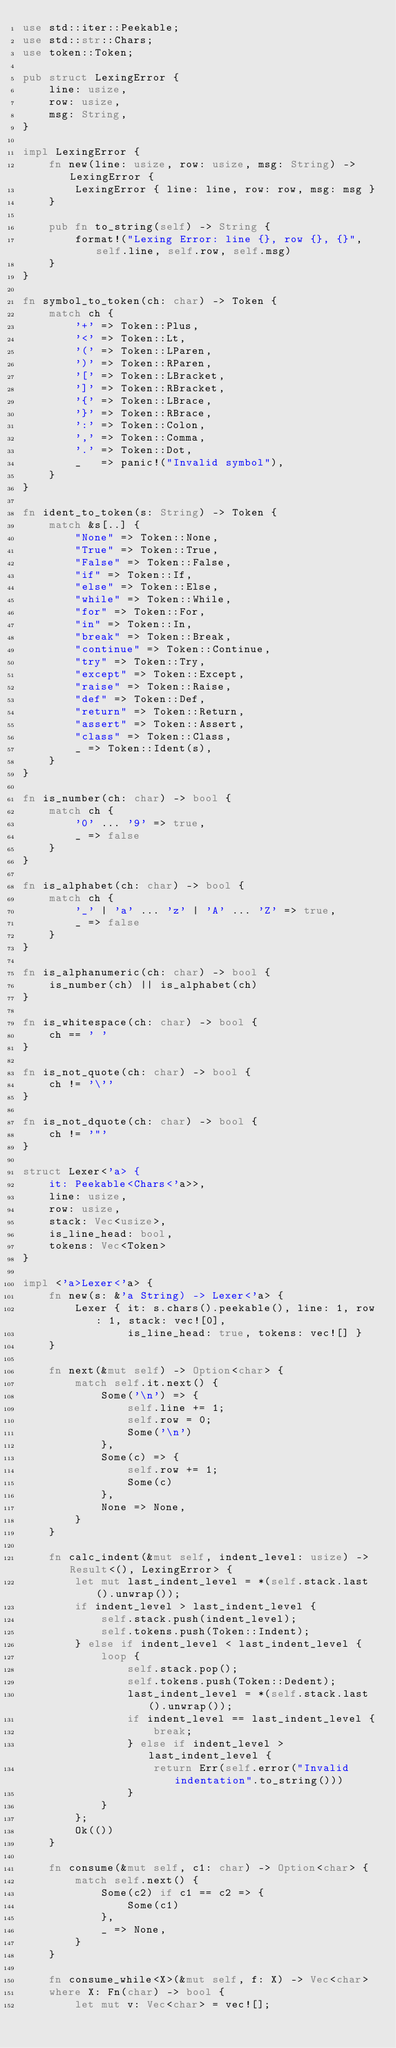<code> <loc_0><loc_0><loc_500><loc_500><_Rust_>use std::iter::Peekable;
use std::str::Chars;
use token::Token;

pub struct LexingError {
    line: usize,
    row: usize,
    msg: String,
}

impl LexingError {
    fn new(line: usize, row: usize, msg: String) -> LexingError {
        LexingError { line: line, row: row, msg: msg }
    }

    pub fn to_string(self) -> String {
        format!("Lexing Error: line {}, row {}, {}", self.line, self.row, self.msg)
    }
}

fn symbol_to_token(ch: char) -> Token {
    match ch {
        '+' => Token::Plus,
        '<' => Token::Lt,
        '(' => Token::LParen,
        ')' => Token::RParen,
        '[' => Token::LBracket,
        ']' => Token::RBracket,
        '{' => Token::LBrace,
        '}' => Token::RBrace,
        ':' => Token::Colon,
        ',' => Token::Comma,
        '.' => Token::Dot,
        _   => panic!("Invalid symbol"),
    }
}

fn ident_to_token(s: String) -> Token {
    match &s[..] {
        "None" => Token::None,
        "True" => Token::True,
        "False" => Token::False,
        "if" => Token::If,
        "else" => Token::Else,
        "while" => Token::While,
        "for" => Token::For,
        "in" => Token::In,
        "break" => Token::Break,
        "continue" => Token::Continue,
        "try" => Token::Try,
        "except" => Token::Except,
        "raise" => Token::Raise,
        "def" => Token::Def,
        "return" => Token::Return,
        "assert" => Token::Assert,
        "class" => Token::Class,
        _ => Token::Ident(s),
    }
}

fn is_number(ch: char) -> bool {
    match ch {
        '0' ... '9' => true,
        _ => false
    }
}

fn is_alphabet(ch: char) -> bool {
    match ch {
        '_' | 'a' ... 'z' | 'A' ... 'Z' => true,
        _ => false
    }
}

fn is_alphanumeric(ch: char) -> bool {
    is_number(ch) || is_alphabet(ch)
}

fn is_whitespace(ch: char) -> bool {
    ch == ' '
}

fn is_not_quote(ch: char) -> bool {
    ch != '\''
}

fn is_not_dquote(ch: char) -> bool {
    ch != '"'
}

struct Lexer<'a> {
    it: Peekable<Chars<'a>>,
    line: usize,
    row: usize,
    stack: Vec<usize>,
    is_line_head: bool,
    tokens: Vec<Token>
}

impl <'a>Lexer<'a> {
    fn new(s: &'a String) -> Lexer<'a> {
        Lexer { it: s.chars().peekable(), line: 1, row: 1, stack: vec![0],
                is_line_head: true, tokens: vec![] }
    }

    fn next(&mut self) -> Option<char> {
        match self.it.next() {
            Some('\n') => {
                self.line += 1;
                self.row = 0;
                Some('\n')
            },
            Some(c) => {
                self.row += 1;
                Some(c)
            },
            None => None,
        }
    }

    fn calc_indent(&mut self, indent_level: usize) -> Result<(), LexingError> {
        let mut last_indent_level = *(self.stack.last().unwrap());
        if indent_level > last_indent_level {
            self.stack.push(indent_level);
            self.tokens.push(Token::Indent);
        } else if indent_level < last_indent_level {
            loop {
                self.stack.pop();
                self.tokens.push(Token::Dedent);
                last_indent_level = *(self.stack.last().unwrap());
                if indent_level == last_indent_level {
                    break;
                } else if indent_level > last_indent_level {
                    return Err(self.error("Invalid indentation".to_string()))
                }
            }
        };
        Ok(())
    }

    fn consume(&mut self, c1: char) -> Option<char> {
        match self.next() {
            Some(c2) if c1 == c2 => {
                Some(c1)
            },
            _ => None,
        }
    }

    fn consume_while<X>(&mut self, f: X) -> Vec<char>
    where X: Fn(char) -> bool {
        let mut v: Vec<char> = vec![];</code> 